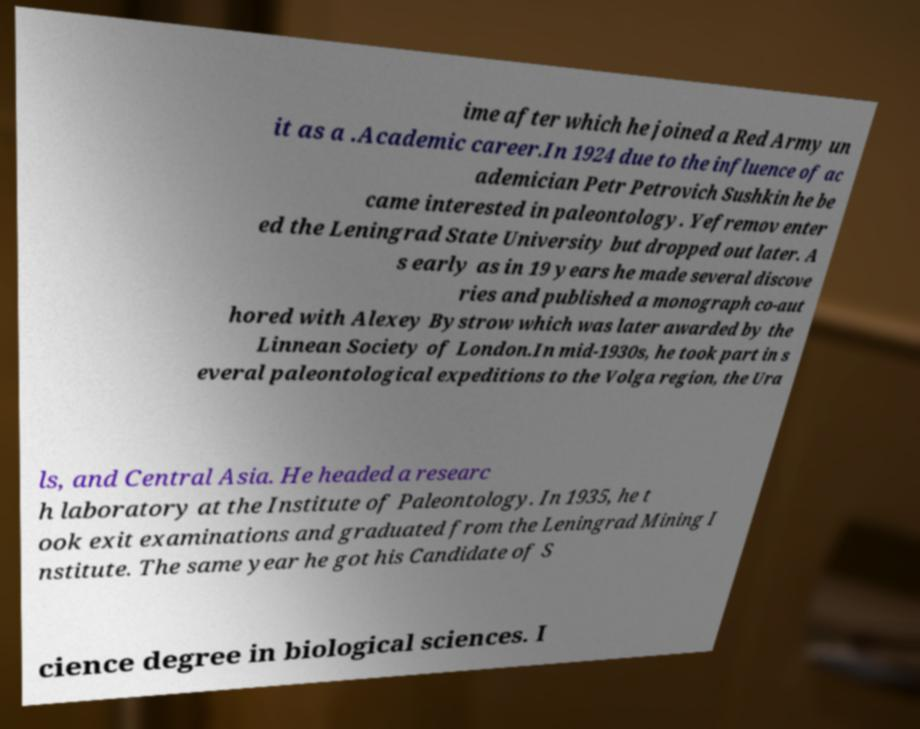I need the written content from this picture converted into text. Can you do that? ime after which he joined a Red Army un it as a .Academic career.In 1924 due to the influence of ac ademician Petr Petrovich Sushkin he be came interested in paleontology. Yefremov enter ed the Leningrad State University but dropped out later. A s early as in 19 years he made several discove ries and published a monograph co-aut hored with Alexey Bystrow which was later awarded by the Linnean Society of London.In mid-1930s, he took part in s everal paleontological expeditions to the Volga region, the Ura ls, and Central Asia. He headed a researc h laboratory at the Institute of Paleontology. In 1935, he t ook exit examinations and graduated from the Leningrad Mining I nstitute. The same year he got his Candidate of S cience degree in biological sciences. I 